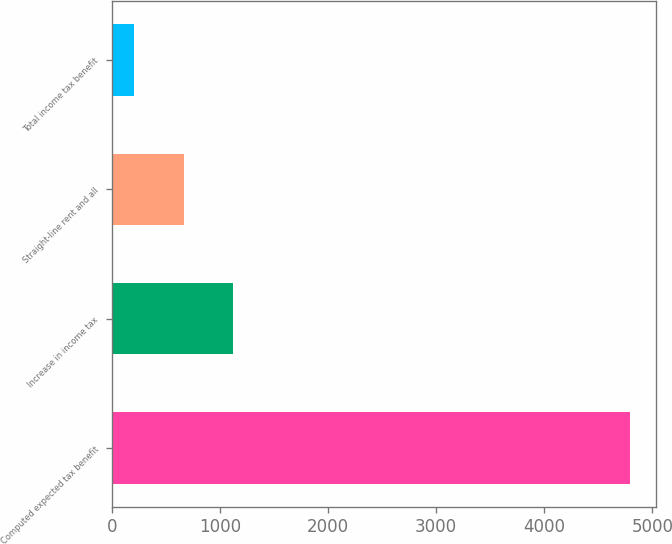Convert chart to OTSL. <chart><loc_0><loc_0><loc_500><loc_500><bar_chart><fcel>Computed expected tax benefit<fcel>Increase in income tax<fcel>Straight-line rent and all<fcel>Total income tax benefit<nl><fcel>4791<fcel>1119.8<fcel>660.9<fcel>202<nl></chart> 